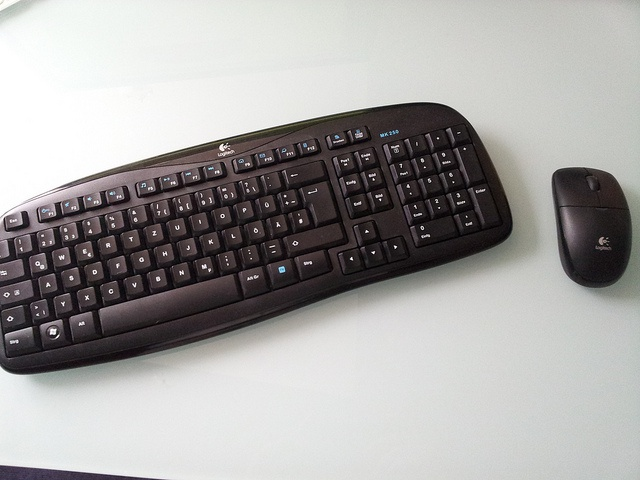Describe the objects in this image and their specific colors. I can see keyboard in ivory, black, gray, and darkgray tones and mouse in ivory, black, gray, and darkgray tones in this image. 